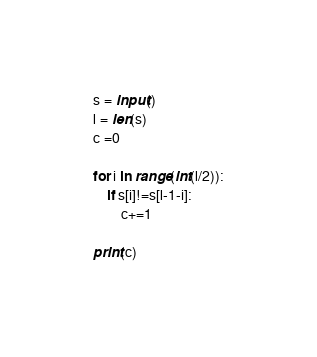Convert code to text. <code><loc_0><loc_0><loc_500><loc_500><_Python_>s = input()
l = len(s)
c =0

for i in range(int(l/2)):
    if s[i]!=s[l-1-i]:
        c+=1

print(c)</code> 